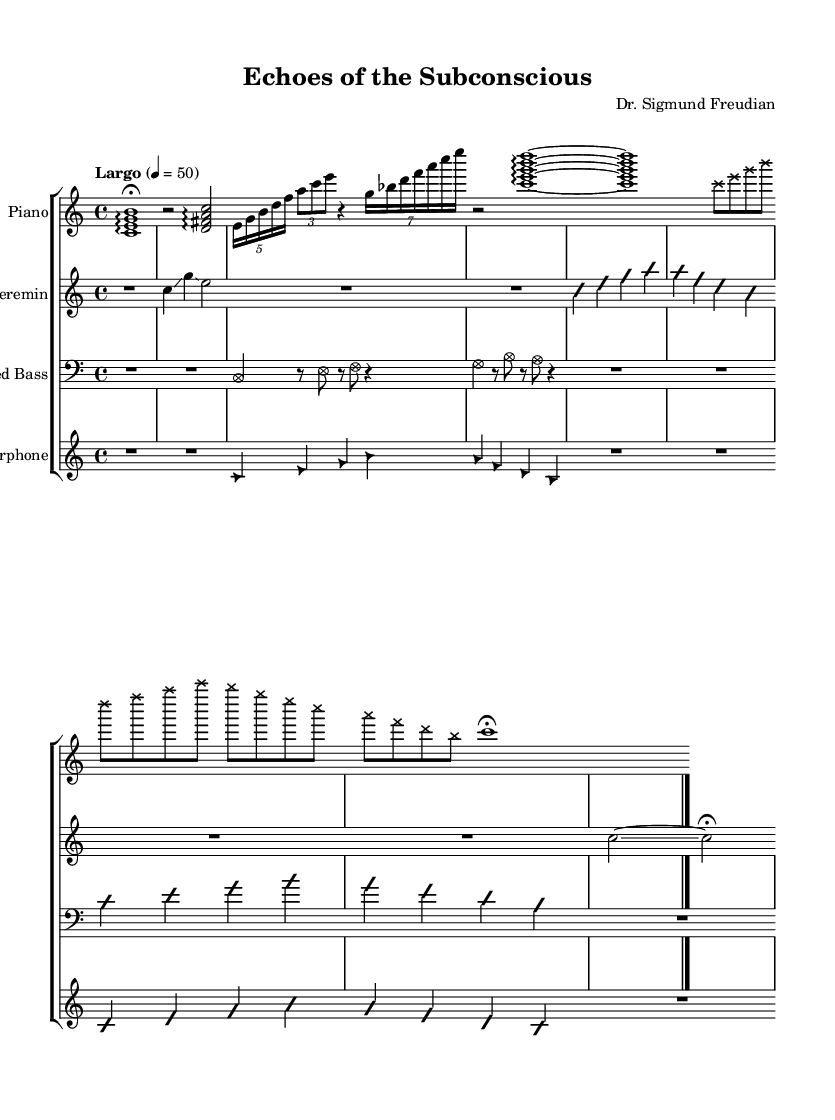What is the time signature of this music? The time signature appears at the beginning of the score as 4/4, indicating there are four beats in each measure and the quarter note gets one beat.
Answer: 4/4 What is the tempo marking for this composition? The tempo marking is indicated as "Largo" with a metronome marking of 50, suggesting that the piece should be played slowly.
Answer: Largo How many sections does the piece have? By analyzing the structure of the composition, there are four distinct sections labeled Introduction, Section A, Section B, and Section C, plus a Coda, leading to a total of five sections.
Answer: 5 What style is indicated for the note heads in Section C of the piano part? The style of the note heads in Section C is specified as 'cross', which alters the visual representation of those notes.
Answer: cross What does the 'improvisationOn' marking signify? The 'improvisationOn' marking indicates that the performer is allowed to improvise during that section, giving them flexibility and freedom in their performance.
Answer: Improvisation In which instruments does the use of glissando appear? Glissando is indicated in the Theremin for the notes C and G in the introduction and again in the Coda of Section C, illustrating expressive slide transitions.
Answer: Theremin What is the instrument used in the bass part? The bass part specifies the instrument as "Prepared Bass," which suggests a non-traditional approach to the instrument, typically used in avant-garde compositions for unique sound effects.
Answer: Prepared Bass 